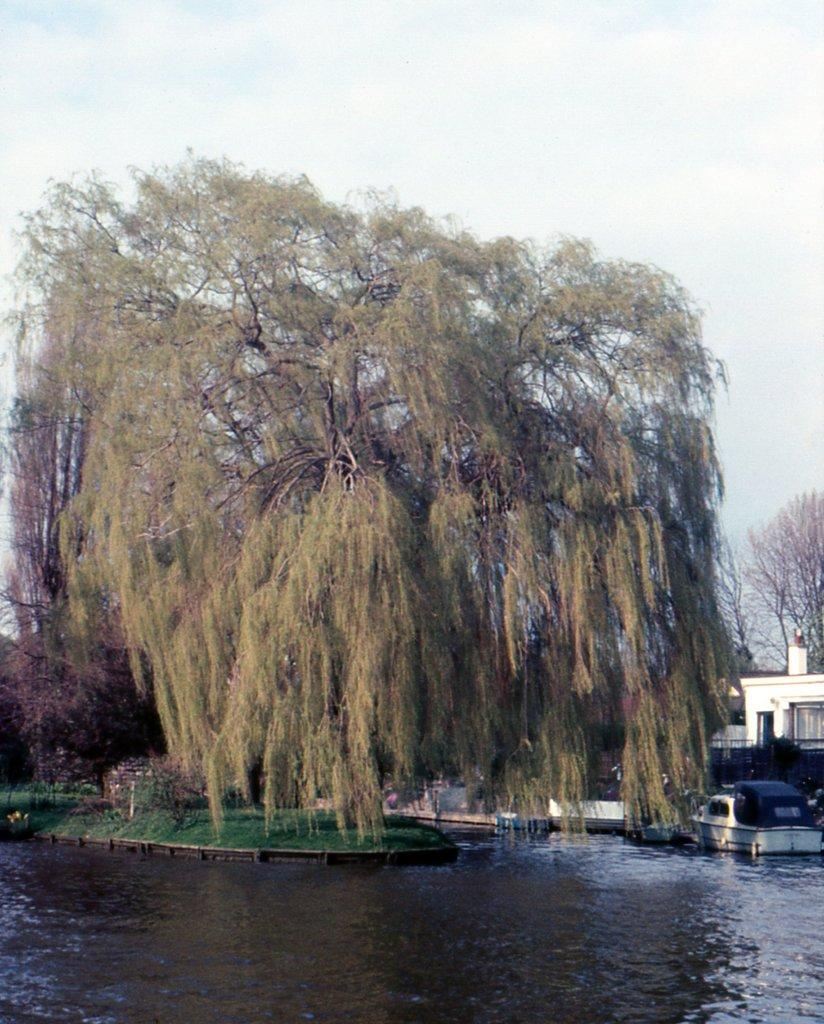What type of natural element can be seen in the image? There is a tree in the image. What can be seen beneath the surface of the ground in the image? Groundwater is visible in the image. What type of man-made structures are present in the image? There are buildings in the image. What is visible above the ground in the image? The sky is visible in the image. What type of atmospheric phenomenon can be seen in the sky? Clouds are present in the sky. What type of bottle is being used for the journey in the image? There is no bottle or journey present in the image. What nation is depicted in the image? The image does not depict any specific nation. 